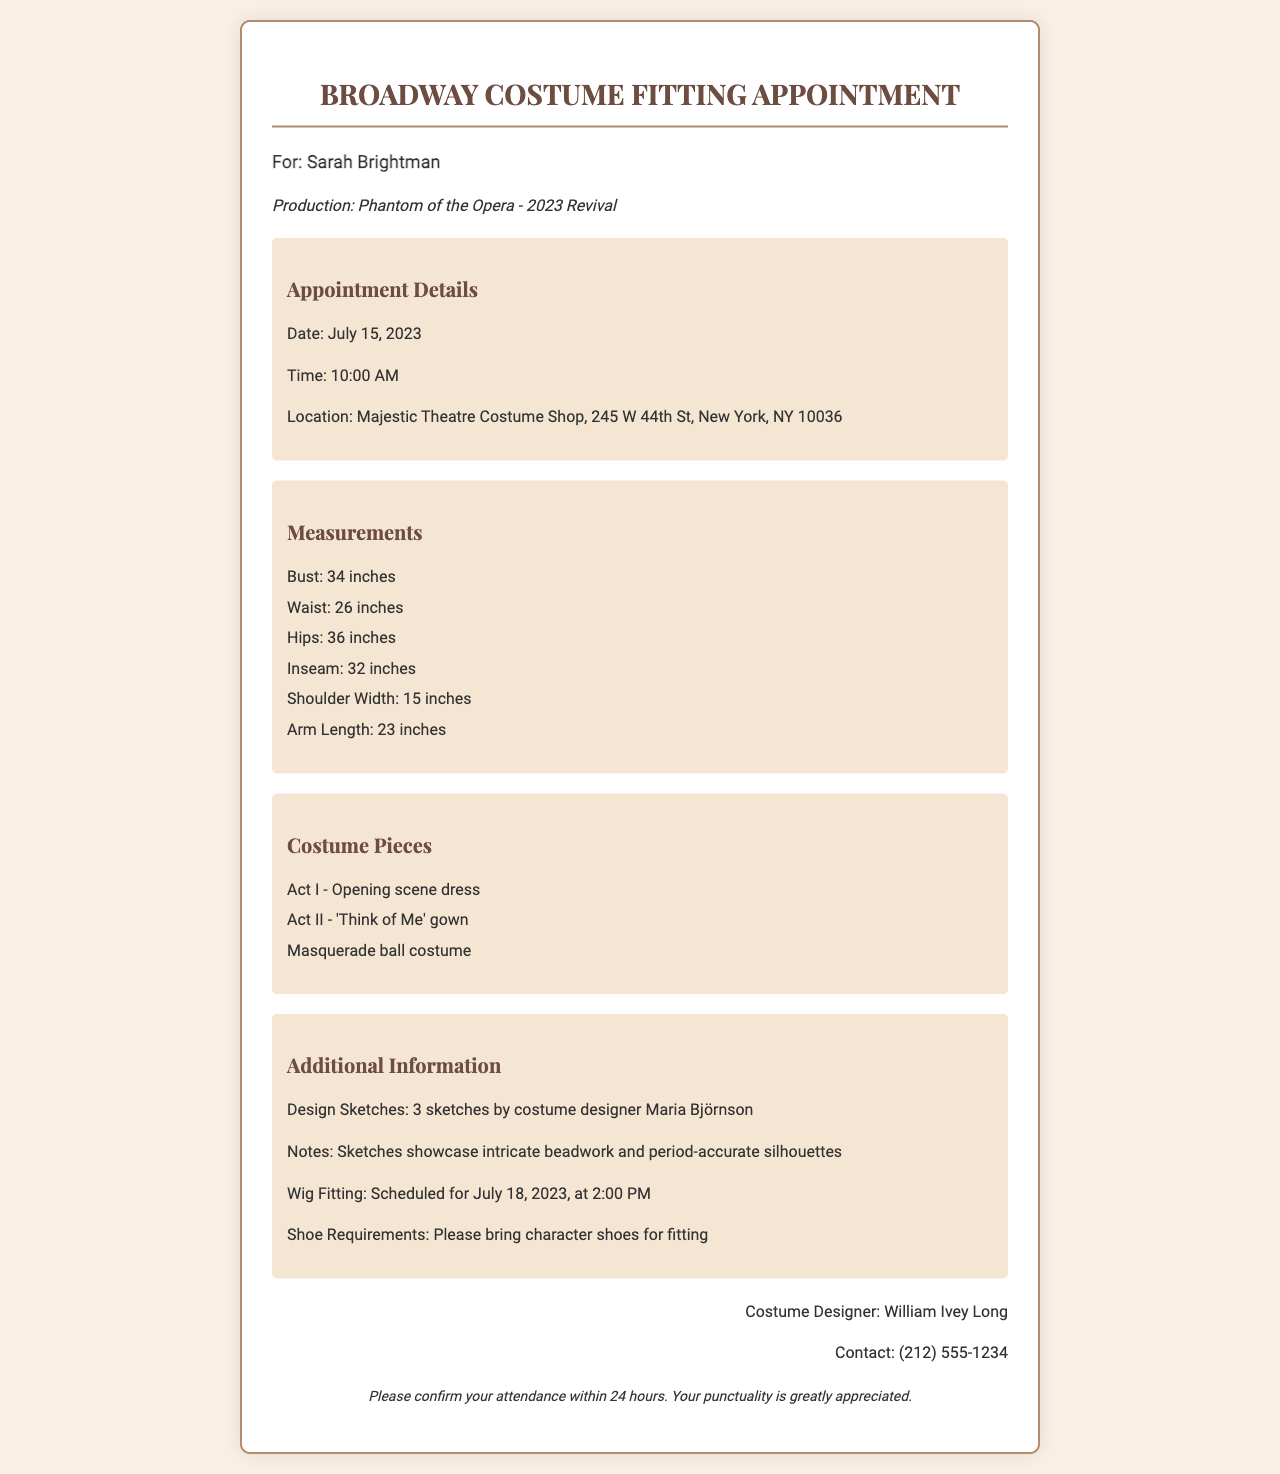What is the appointment date? The appointment date is stated directly in the document under the Appointment Details section.
Answer: July 15, 2023 Who is the costume designer? The name of the costume designer is provided at the bottom of the document in the contact section.
Answer: William Ivey Long What is the location of the fitting? The fitting location is detailed in the Appointment Details section of the document.
Answer: Majestic Theatre Costume Shop, 245 W 44th St, New York, NY 10036 How many design sketches are there? The number of design sketches is mentioned in the Additional Information section of the document.
Answer: 3 sketches What is the time of the appointment? The appointment time is given in the Appointment Details section of the document.
Answer: 10:00 AM What types of costumes will be fitted? The types of costumes are listed in the Costume Pieces section of the document.
Answer: Act I - Opening scene dress, Act II - 'Think of Me' gown, Masquerade ball costume What is the shoe requirement? The shoe requirement is specified in the Additional Information section of the document.
Answer: Please bring character shoes for fitting When is the wig fitting scheduled? The date and time for the wig fitting are included in the Additional Information section of the document.
Answer: July 18, 2023, at 2:00 PM What should Sarah confirm within 24 hours? The document requests a confirmation regarding attendance outlined in the footer.
Answer: Attendance 